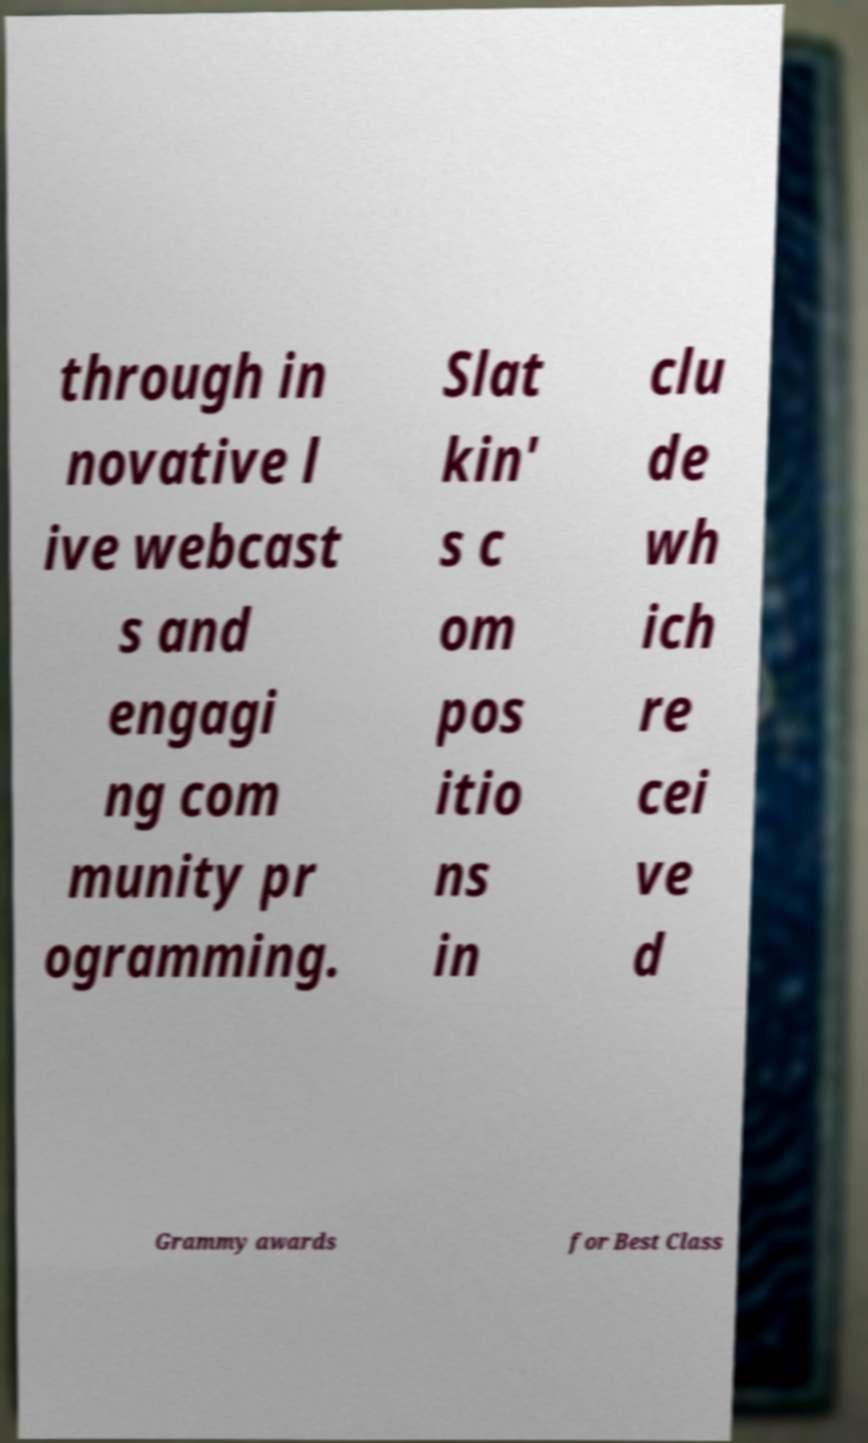I need the written content from this picture converted into text. Can you do that? through in novative l ive webcast s and engagi ng com munity pr ogramming. Slat kin' s c om pos itio ns in clu de wh ich re cei ve d Grammy awards for Best Class 